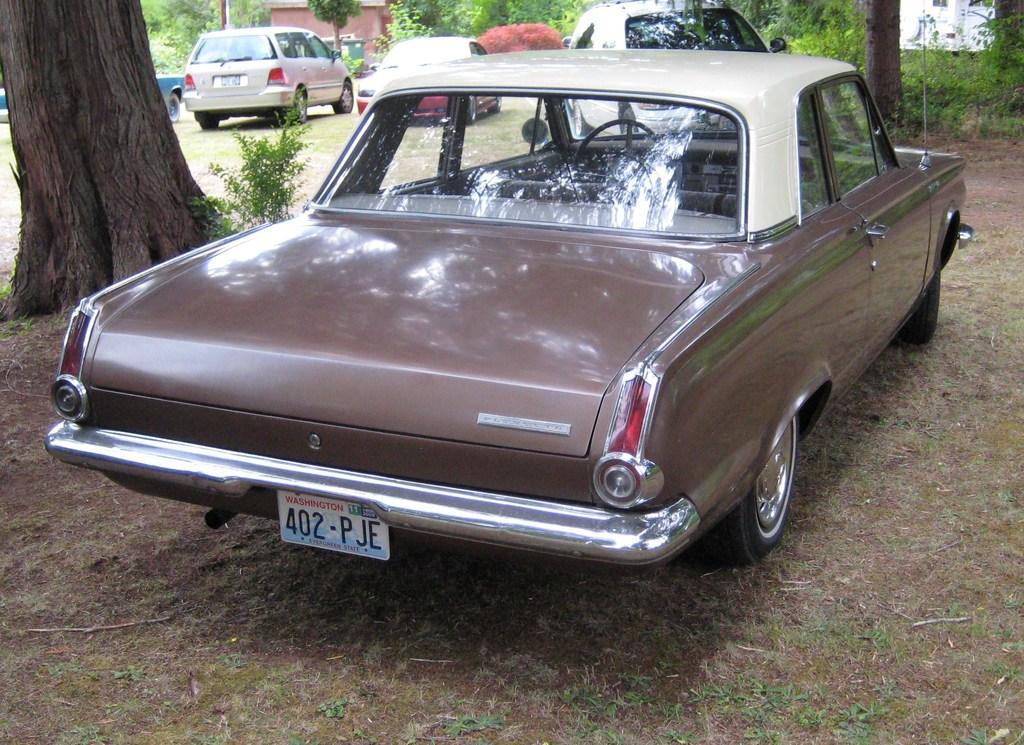What is located in the foreground of the picture? There is a plant, a tree, and a car in the foreground of the picture. What type of surface is visible in the foreground? There is soil in the foreground of the picture. What can be seen in the background of the picture? There are cars, trees, buildings, and plants in the background of the picture. What type of surprise can be seen in the sky in the image? There is no surprise visible in the sky in the image. Can you tell me how many firemen are present in the image? There are no firemen present in the image. 